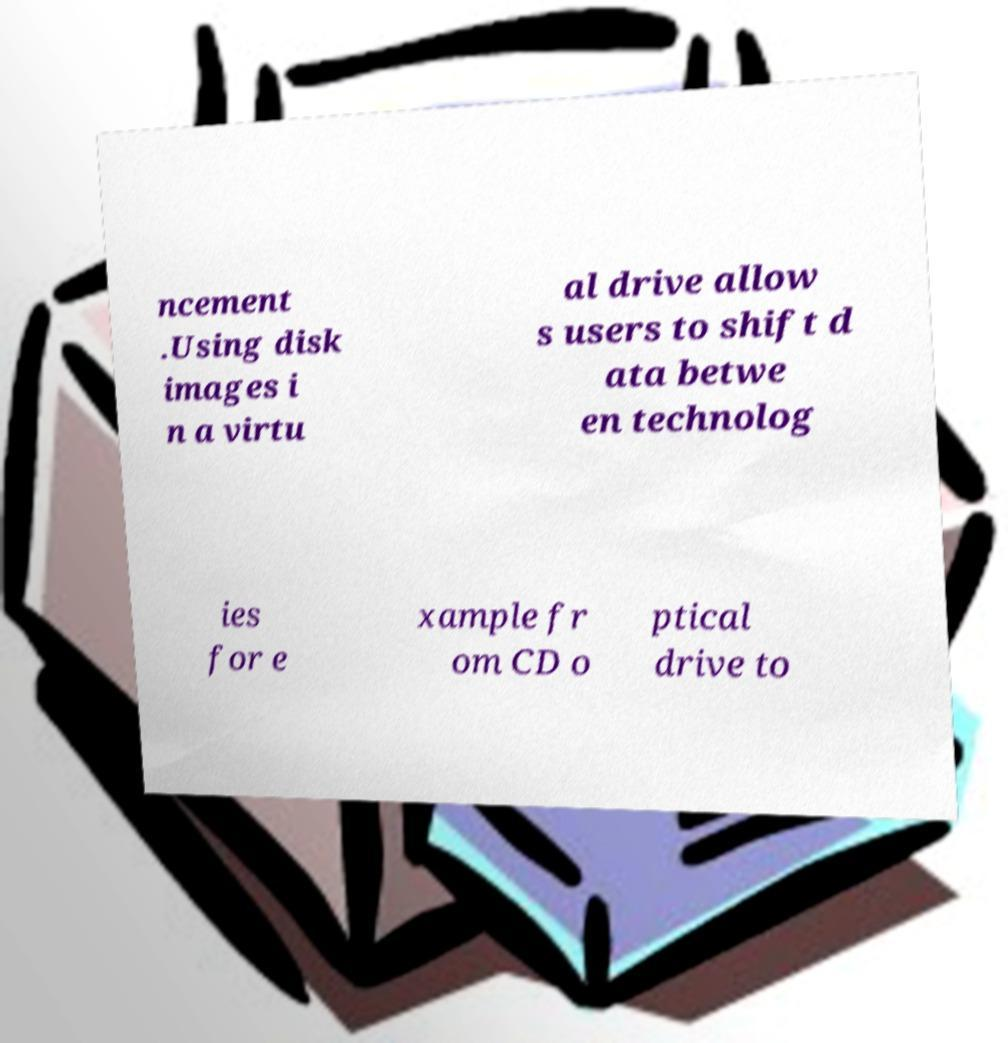There's text embedded in this image that I need extracted. Can you transcribe it verbatim? ncement .Using disk images i n a virtu al drive allow s users to shift d ata betwe en technolog ies for e xample fr om CD o ptical drive to 